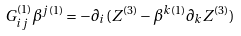<formula> <loc_0><loc_0><loc_500><loc_500>G _ { i j } ^ { ( 1 ) } \beta ^ { j ( 1 ) } = - \partial _ { i } ( Z ^ { ( 3 ) } - \beta ^ { k ( 1 ) } \partial _ { k } Z ^ { ( 3 ) } )</formula> 